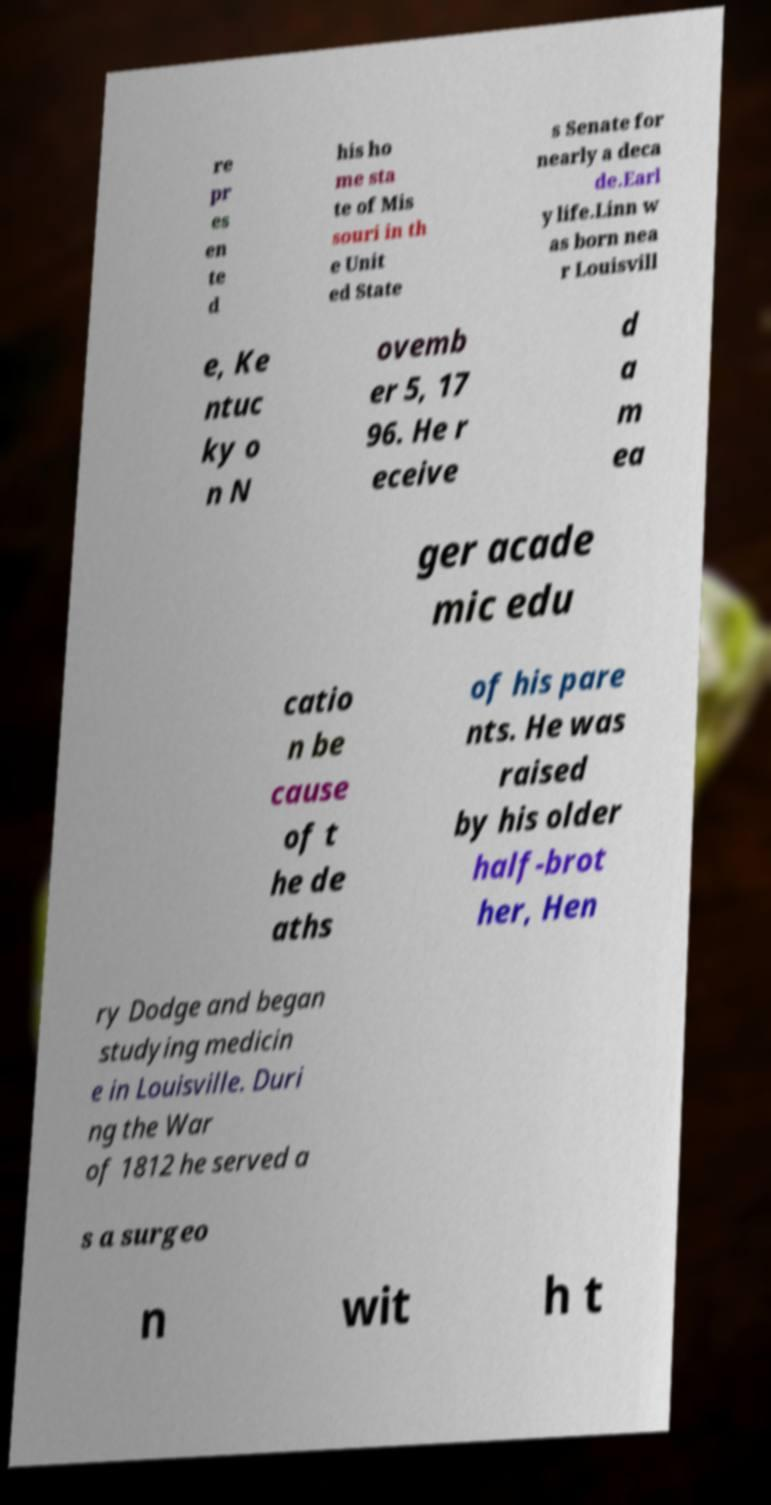Can you read and provide the text displayed in the image?This photo seems to have some interesting text. Can you extract and type it out for me? re pr es en te d his ho me sta te of Mis souri in th e Unit ed State s Senate for nearly a deca de.Earl y life.Linn w as born nea r Louisvill e, Ke ntuc ky o n N ovemb er 5, 17 96. He r eceive d a m ea ger acade mic edu catio n be cause of t he de aths of his pare nts. He was raised by his older half-brot her, Hen ry Dodge and began studying medicin e in Louisville. Duri ng the War of 1812 he served a s a surgeo n wit h t 